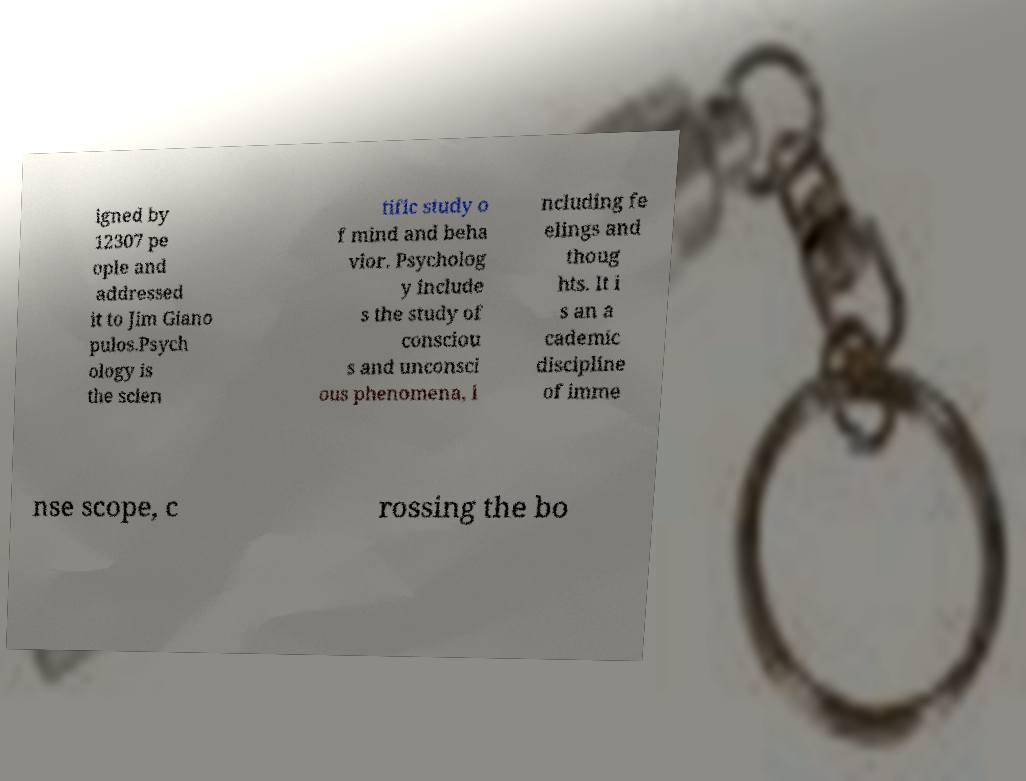Could you assist in decoding the text presented in this image and type it out clearly? igned by 12307 pe ople and addressed it to Jim Giano pulos.Psych ology is the scien tific study o f mind and beha vior. Psycholog y include s the study of consciou s and unconsci ous phenomena, i ncluding fe elings and thoug hts. It i s an a cademic discipline of imme nse scope, c rossing the bo 